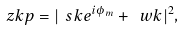<formula> <loc_0><loc_0><loc_500><loc_500>\ z k p = | \ s k e ^ { i \phi _ { m } } + \ w k | ^ { 2 } ,</formula> 